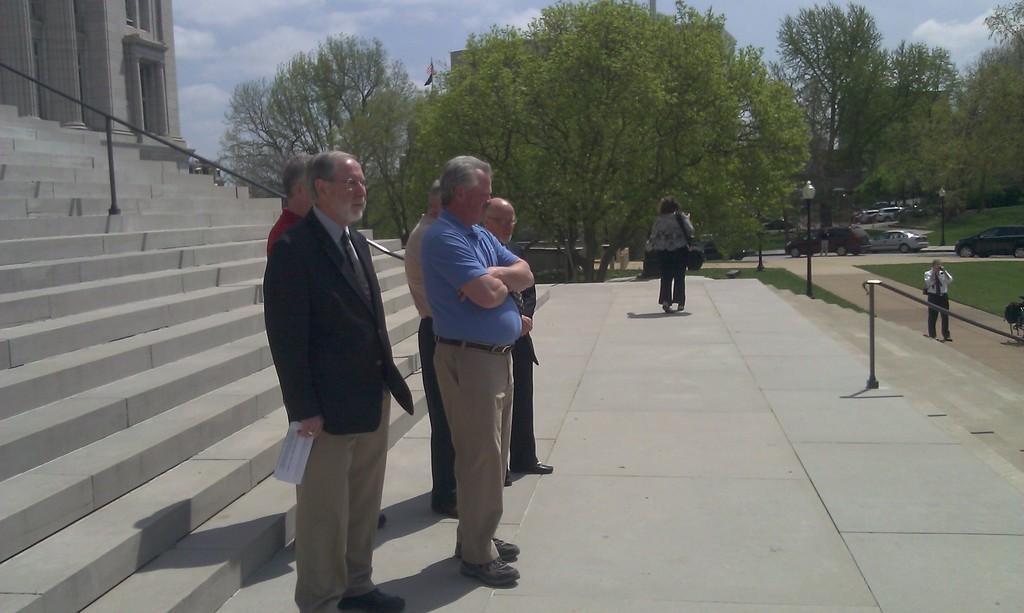Can you describe this image briefly? In the center of the image some persons are standing. In the background of the image we can see trees, electric light poles, cars, some persons, grass. On the left side of the image we can see building, pillars, windows, rods, stairs. On the right side of the image there is a ground. At the top of the image clouds are present in the sky. At the bottom of the image there is a floor. 